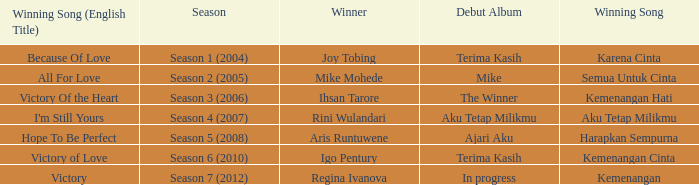Which winning song was sung by aku tetap milikmu? I'm Still Yours. 